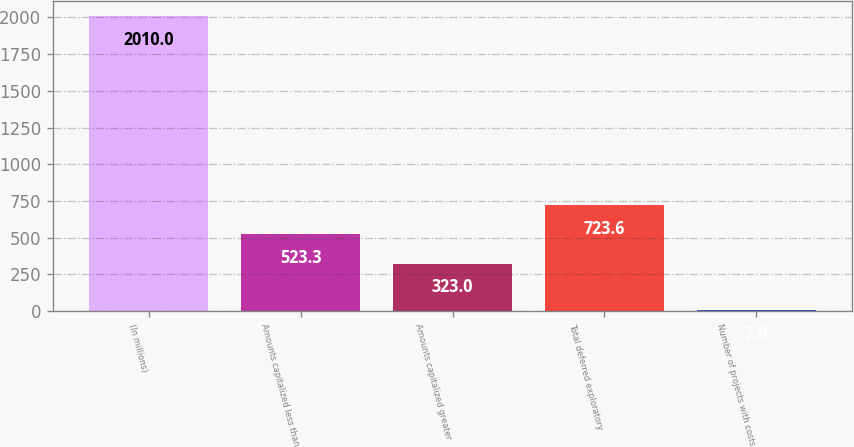<chart> <loc_0><loc_0><loc_500><loc_500><bar_chart><fcel>(In millions)<fcel>Amounts capitalized less than<fcel>Amounts capitalized greater<fcel>Total deferred exploratory<fcel>Number of projects with costs<nl><fcel>2010<fcel>523.3<fcel>323<fcel>723.6<fcel>7<nl></chart> 